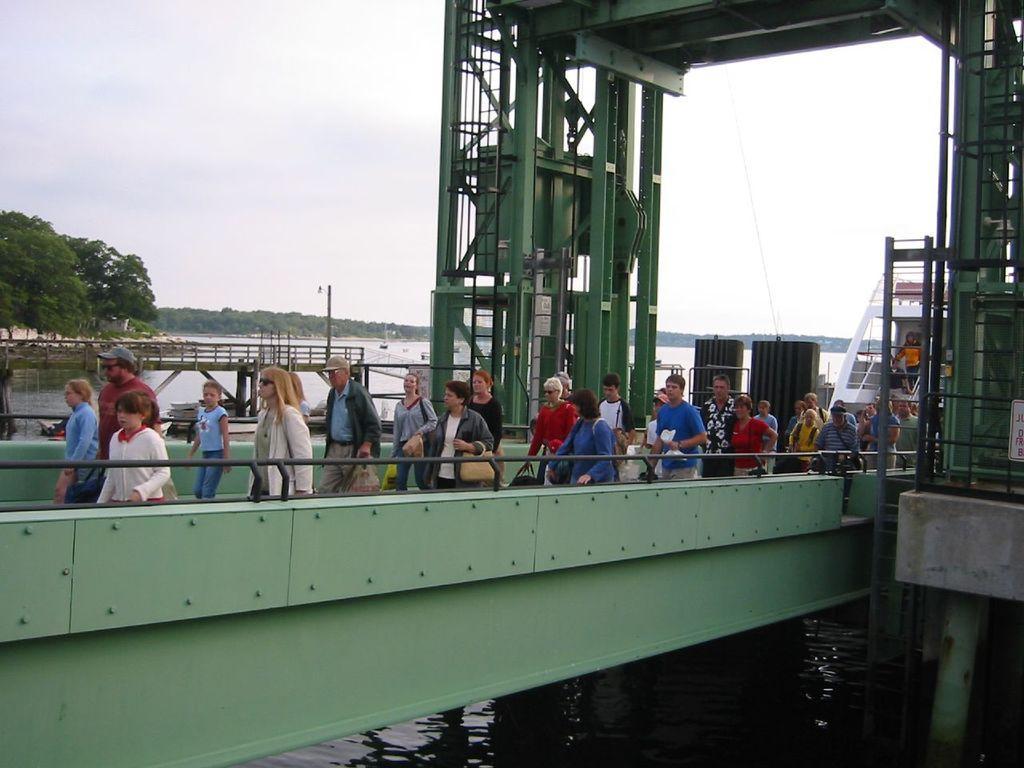Describe this image in one or two sentences. In this image, we can see a group of people. Here we can see a bridge, rods, water, trees, poles, pillars. Background there is a sky. 